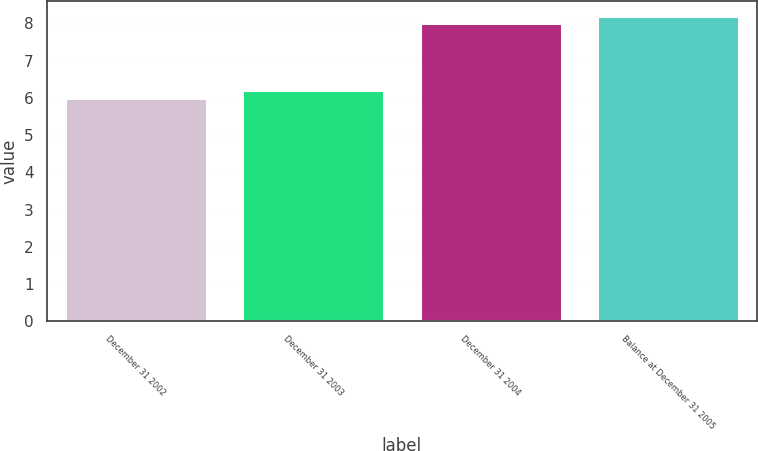<chart> <loc_0><loc_0><loc_500><loc_500><bar_chart><fcel>December 31 2002<fcel>December 31 2003<fcel>December 31 2004<fcel>Balance at December 31 2005<nl><fcel>6<fcel>6.2<fcel>8<fcel>8.2<nl></chart> 